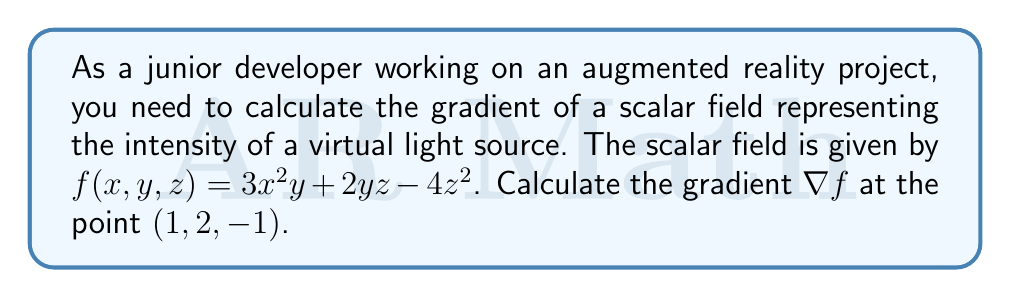Give your solution to this math problem. To calculate the gradient of a scalar field in 3D space, we need to find the partial derivatives with respect to x, y, and z. The gradient is then expressed as a vector of these partial derivatives:

$$\nabla f = \left(\frac{\partial f}{\partial x}, \frac{\partial f}{\partial y}, \frac{\partial f}{\partial z}\right)$$

Let's calculate each partial derivative:

1. $\frac{\partial f}{\partial x}$:
   $$\frac{\partial f}{\partial x} = \frac{\partial}{\partial x}(3x^2y + 2yz - 4z^2) = 6xy$$

2. $\frac{\partial f}{\partial y}$:
   $$\frac{\partial f}{\partial y} = \frac{\partial}{\partial y}(3x^2y + 2yz - 4z^2) = 3x^2 + 2z$$

3. $\frac{\partial f}{\partial z}$:
   $$\frac{\partial f}{\partial z} = \frac{\partial}{\partial z}(3x^2y + 2yz - 4z^2) = 2y - 8z$$

Now we have the gradient in general form:

$$\nabla f = (6xy, 3x^2 + 2z, 2y - 8z)$$

To find the gradient at the point $(1, 2, -1)$, we substitute these values into our gradient vector:

$$\nabla f(1, 2, -1) = (6(1)(2), 3(1)^2 + 2(-1), 2(2) - 8(-1))$$
$$= (12, 3 - 2, 4 + 8)$$
$$= (12, 1, 12)$$

Therefore, the gradient of the scalar field at the point $(1, 2, -1)$ is $(12, 1, 12)$.
Answer: $(12, 1, 12)$ 